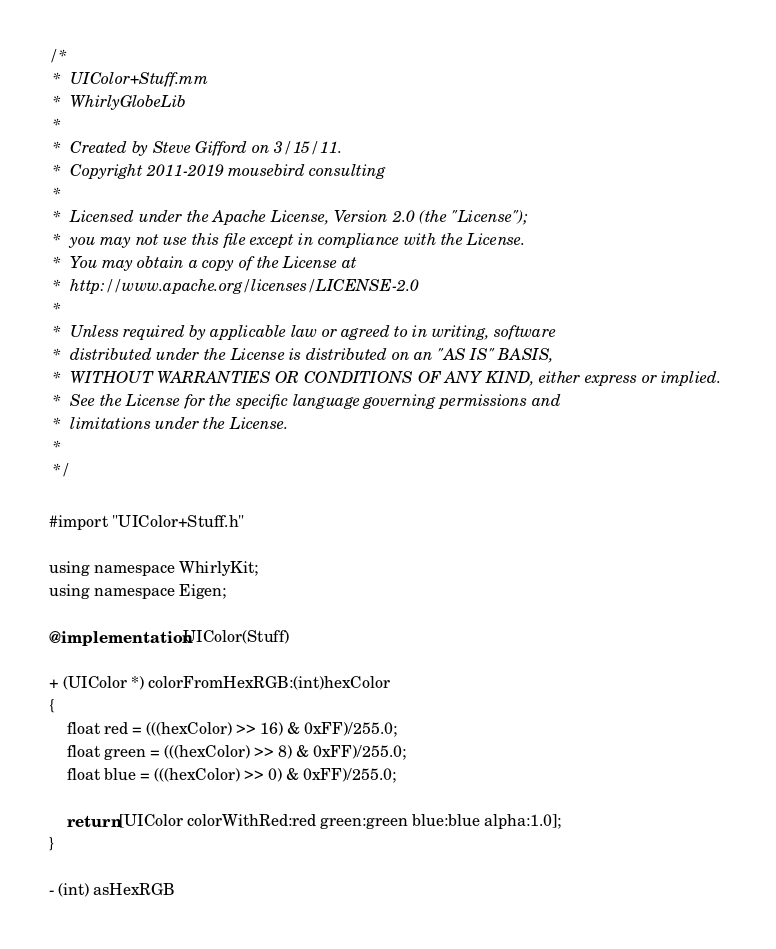<code> <loc_0><loc_0><loc_500><loc_500><_ObjectiveC_>/*
 *  UIColor+Stuff.mm
 *  WhirlyGlobeLib
 *
 *  Created by Steve Gifford on 3/15/11.
 *  Copyright 2011-2019 mousebird consulting
 *
 *  Licensed under the Apache License, Version 2.0 (the "License");
 *  you may not use this file except in compliance with the License.
 *  You may obtain a copy of the License at
 *  http://www.apache.org/licenses/LICENSE-2.0
 *
 *  Unless required by applicable law or agreed to in writing, software
 *  distributed under the License is distributed on an "AS IS" BASIS,
 *  WITHOUT WARRANTIES OR CONDITIONS OF ANY KIND, either express or implied.
 *  See the License for the specific language governing permissions and
 *  limitations under the License.
 *
 */

#import "UIColor+Stuff.h"

using namespace WhirlyKit;
using namespace Eigen;

@implementation UIColor(Stuff)

+ (UIColor *) colorFromHexRGB:(int)hexColor
{
    float red = (((hexColor) >> 16) & 0xFF)/255.0;
    float green = (((hexColor) >> 8) & 0xFF)/255.0;
    float blue = (((hexColor) >> 0) & 0xFF)/255.0;
    
    return [UIColor colorWithRed:red green:green blue:blue alpha:1.0];
}

- (int) asHexRGB</code> 